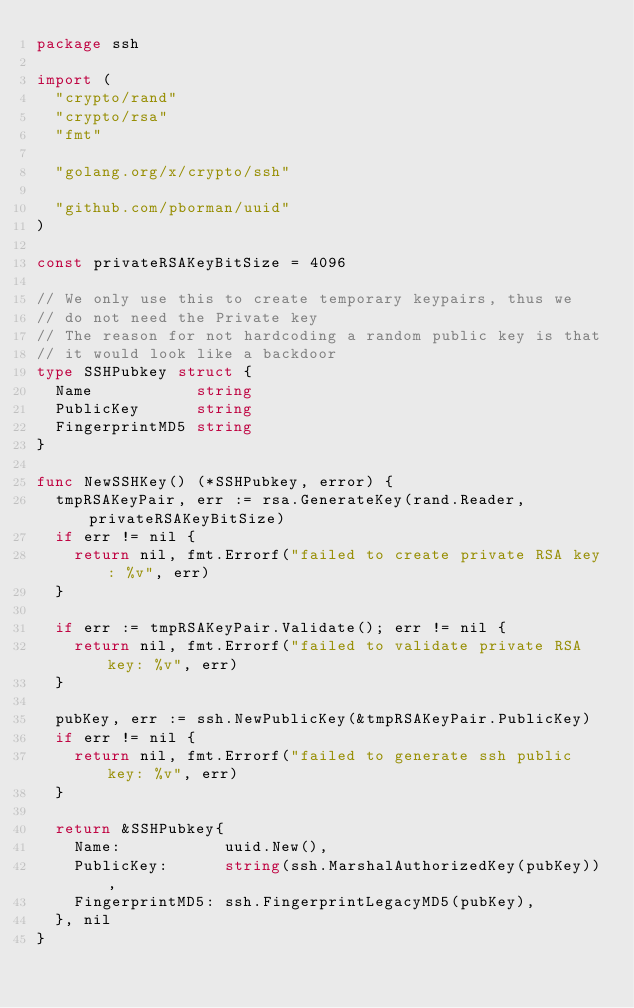<code> <loc_0><loc_0><loc_500><loc_500><_Go_>package ssh

import (
	"crypto/rand"
	"crypto/rsa"
	"fmt"

	"golang.org/x/crypto/ssh"

	"github.com/pborman/uuid"
)

const privateRSAKeyBitSize = 4096

// We only use this to create temporary keypairs, thus we
// do not need the Private key
// The reason for not hardcoding a random public key is that
// it would look like a backdoor
type SSHPubkey struct {
	Name           string
	PublicKey      string
	FingerprintMD5 string
}

func NewSSHKey() (*SSHPubkey, error) {
	tmpRSAKeyPair, err := rsa.GenerateKey(rand.Reader, privateRSAKeyBitSize)
	if err != nil {
		return nil, fmt.Errorf("failed to create private RSA key: %v", err)
	}

	if err := tmpRSAKeyPair.Validate(); err != nil {
		return nil, fmt.Errorf("failed to validate private RSA key: %v", err)
	}

	pubKey, err := ssh.NewPublicKey(&tmpRSAKeyPair.PublicKey)
	if err != nil {
		return nil, fmt.Errorf("failed to generate ssh public key: %v", err)
	}

	return &SSHPubkey{
		Name:           uuid.New(),
		PublicKey:      string(ssh.MarshalAuthorizedKey(pubKey)),
		FingerprintMD5: ssh.FingerprintLegacyMD5(pubKey),
	}, nil
}
</code> 